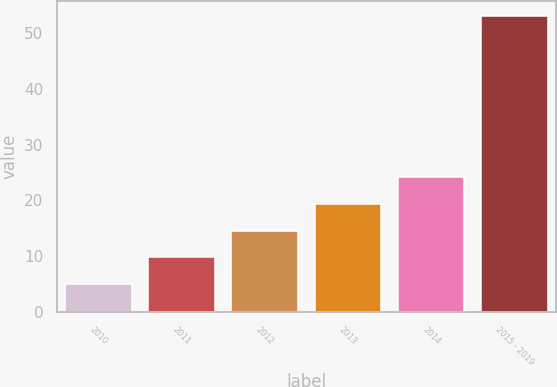Convert chart to OTSL. <chart><loc_0><loc_0><loc_500><loc_500><bar_chart><fcel>2010<fcel>2011<fcel>2012<fcel>2013<fcel>2014<fcel>2015 - 2019<nl><fcel>5<fcel>9.8<fcel>14.6<fcel>19.4<fcel>24.2<fcel>53<nl></chart> 